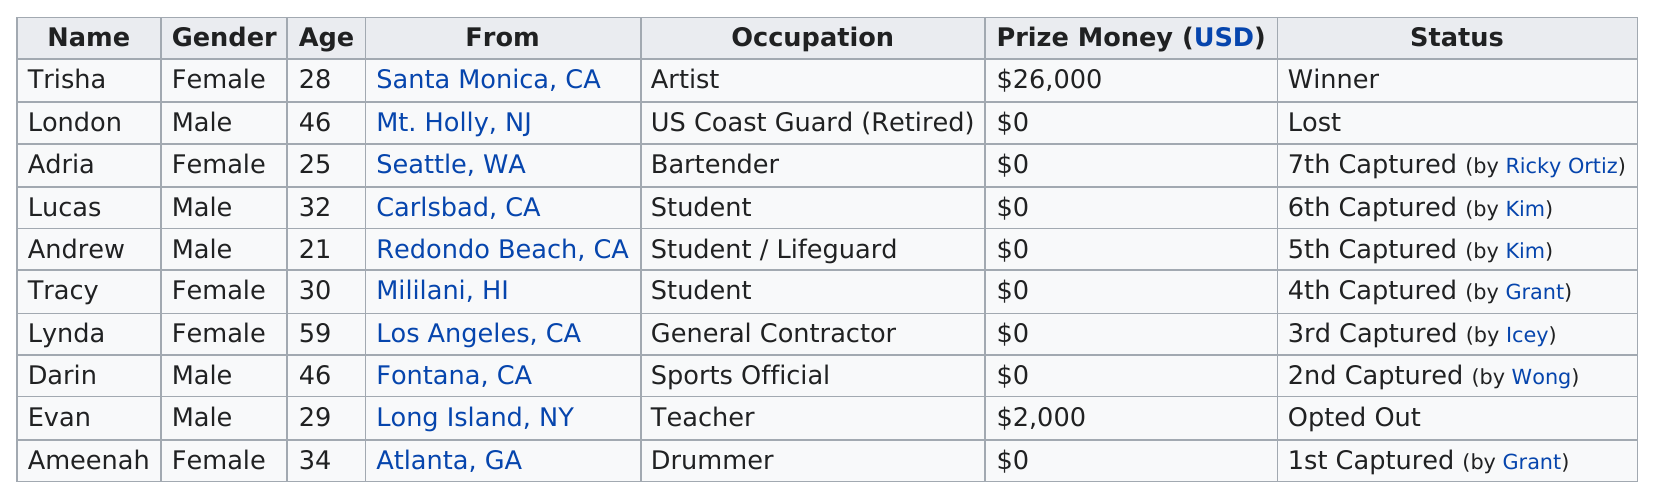Outline some significant characteristics in this image. Trisha was the winner of the top prize in the cha$e competition. Out of the total number of contestants, 5 were male. The total prize money for the contestants from California is $26,000. Adria is the youngest female contestant on the show Cha$e, but she is not the youngest overall. Adria was the only contestant captured by Ricky Ortiz. 